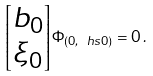<formula> <loc_0><loc_0><loc_500><loc_500>\begin{bmatrix} b _ { 0 } \\ \xi _ { 0 } \end{bmatrix} \Phi _ { ( 0 , \ h s 0 ) } = 0 \, .</formula> 